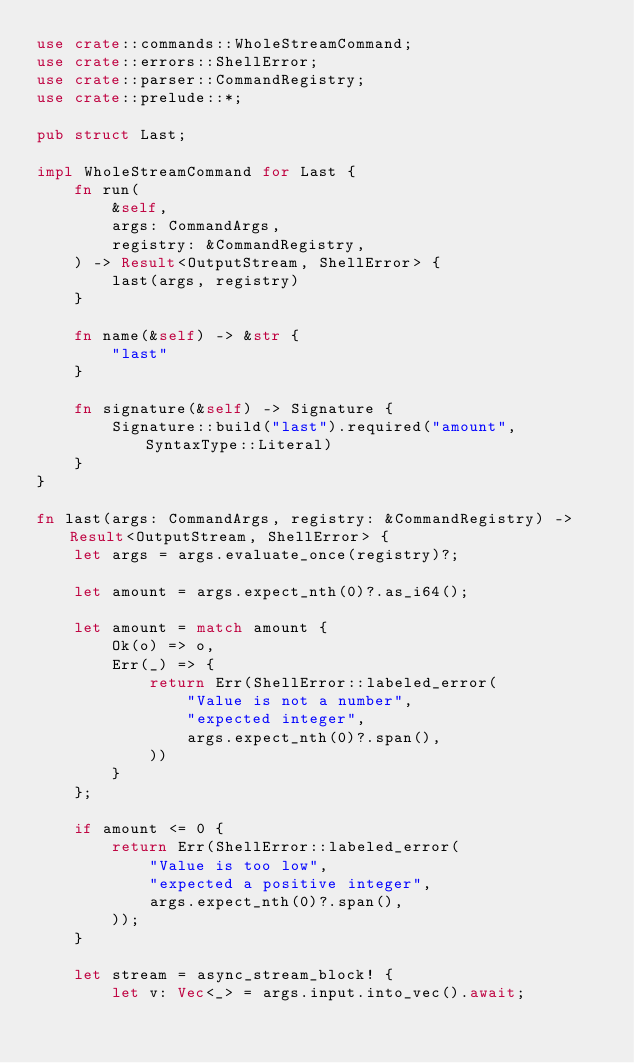<code> <loc_0><loc_0><loc_500><loc_500><_Rust_>use crate::commands::WholeStreamCommand;
use crate::errors::ShellError;
use crate::parser::CommandRegistry;
use crate::prelude::*;

pub struct Last;

impl WholeStreamCommand for Last {
    fn run(
        &self,
        args: CommandArgs,
        registry: &CommandRegistry,
    ) -> Result<OutputStream, ShellError> {
        last(args, registry)
    }

    fn name(&self) -> &str {
        "last"
    }

    fn signature(&self) -> Signature {
        Signature::build("last").required("amount", SyntaxType::Literal)
    }
}

fn last(args: CommandArgs, registry: &CommandRegistry) -> Result<OutputStream, ShellError> {
    let args = args.evaluate_once(registry)?;

    let amount = args.expect_nth(0)?.as_i64();

    let amount = match amount {
        Ok(o) => o,
        Err(_) => {
            return Err(ShellError::labeled_error(
                "Value is not a number",
                "expected integer",
                args.expect_nth(0)?.span(),
            ))
        }
    };

    if amount <= 0 {
        return Err(ShellError::labeled_error(
            "Value is too low",
            "expected a positive integer",
            args.expect_nth(0)?.span(),
        ));
    }

    let stream = async_stream_block! {
        let v: Vec<_> = args.input.into_vec().await;</code> 